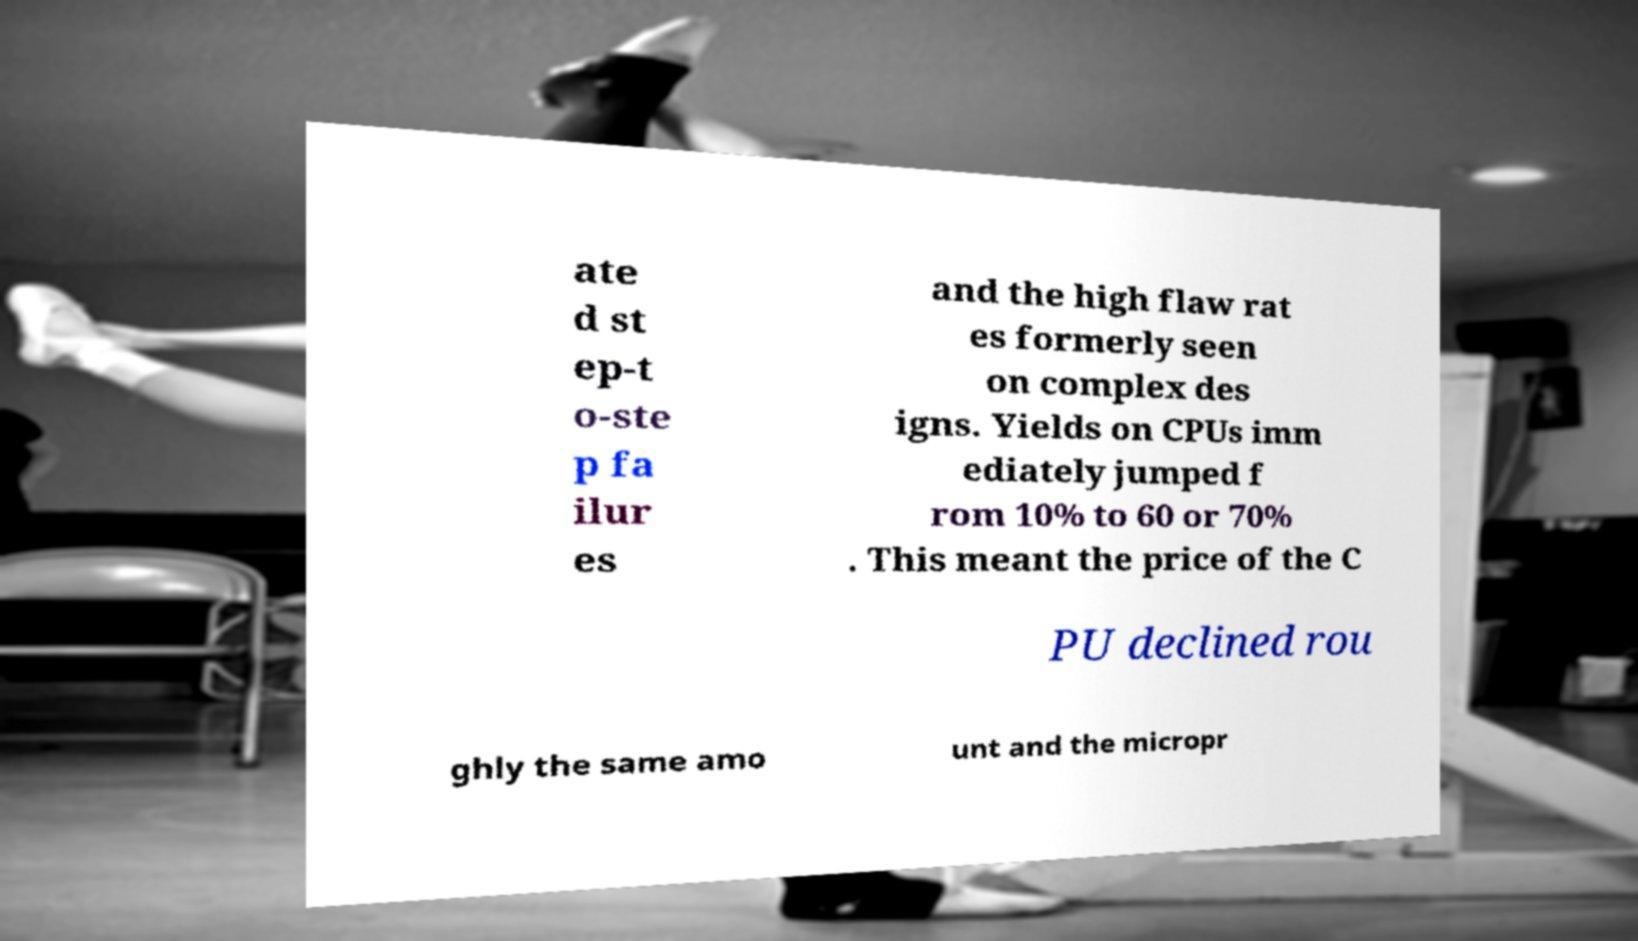I need the written content from this picture converted into text. Can you do that? ate d st ep-t o-ste p fa ilur es and the high flaw rat es formerly seen on complex des igns. Yields on CPUs imm ediately jumped f rom 10% to 60 or 70% . This meant the price of the C PU declined rou ghly the same amo unt and the micropr 